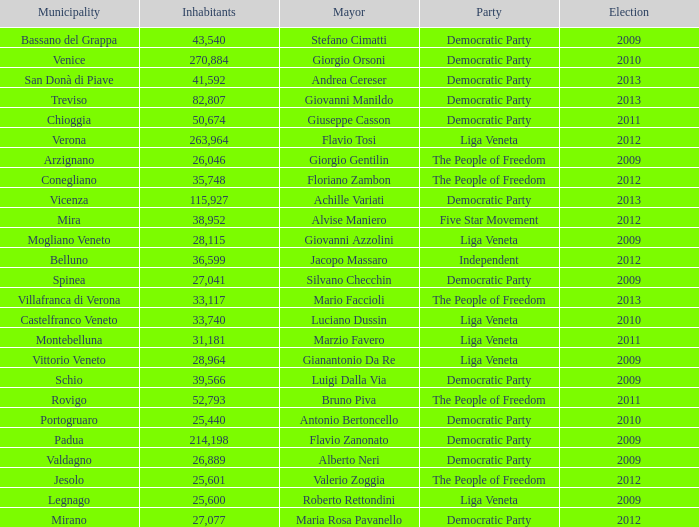How many elections had more than 36,599 inhabitants when Mayor was giovanni manildo? 1.0. 